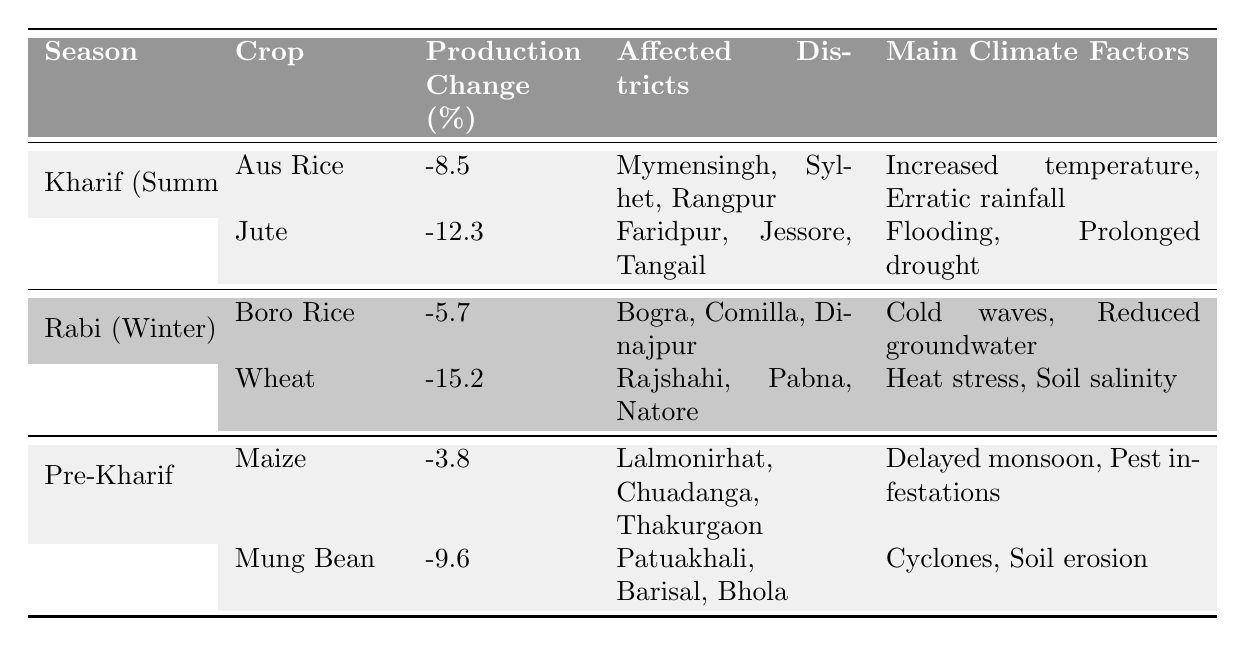What is the production change percentage for Jute? The table shows that Jute has a production change of -12.3%. This value is directly visible in the table under the "Production Change (%)" column for the Kharif season.
Answer: -12.3% Which season has the highest negative production change percentage? By comparing the production change percentages across all seasons and crops, Wheat has the highest negative value of -15.2%. This value is found in the Rabi season section under Wheat.
Answer: Rabi (Winter) Which districts are affected by flooding as a result of climate change? From the table, the districts affected by flooding are Faridpur, Jessore, and Tangail, as stated in the section for Jute under Kharif (Summer).
Answer: Faridpur, Jessore, Tangail What is the average production change percentage for crops in the Kharif season? The production change percentages for Kharif crops are -8.5% (Aus Rice) and -12.3% (Jute). Calculating the average: (-8.5 - 12.3) / 2 = -10.4%.
Answer: -10.4% Which crop in the Pre-Kharif season has the least negative impact in terms of production change? From the Pre-Kharif crop data, Maize has a production change of -3.8%, while Mung Bean has -9.6%. Thus, Maize has the least negative impact.
Answer: Maize Is the production change for Boro Rice greater than that for Aus Rice? Boro Rice has a production change of -5.7%, while Aus Rice has -8.5%. Since -5.7% is greater than -8.5%, the statement is true.
Answer: Yes Which main climate factor is common between Aus Rice and Mung Bean? In the table, Aus Rice is affected by "Increased temperature, Erratic rainfall," and Mung Bean is affected by "Cyclones, Soil erosion." There are no common factors.
Answer: No What is the total number of affected districts across all crops in the Rabi season? The affected districts for Rabi crops are Bogra, Comilla, Dinajpur for Boro Rice (3 districts) and Rajshahi, Pabna, Natore for Wheat (3 districts), totaling 6 unique affected districts.
Answer: 6 Which crop in Rabi experiences a reduction due to cold waves? The table indicates that Boro Rice is affected by cold waves, as shown in the main climate factors for that crop under the Rabi season.
Answer: Boro Rice How do flooding and prolonged drought affect crops in Kharif season? Flooding affects Jute, and the main climate factors for Jute are listed as flooding and prolonged drought. Thus, both factors impact Jute's production in the Kharif season.
Answer: Jute What is the total production change percentage for all crops in the Kharif season? The production change percentages for Kharif crops are -8.5% (Aus Rice) and -12.3% (Jute). The total is -8.5 + (-12.3) = -20.8%.
Answer: -20.8% 